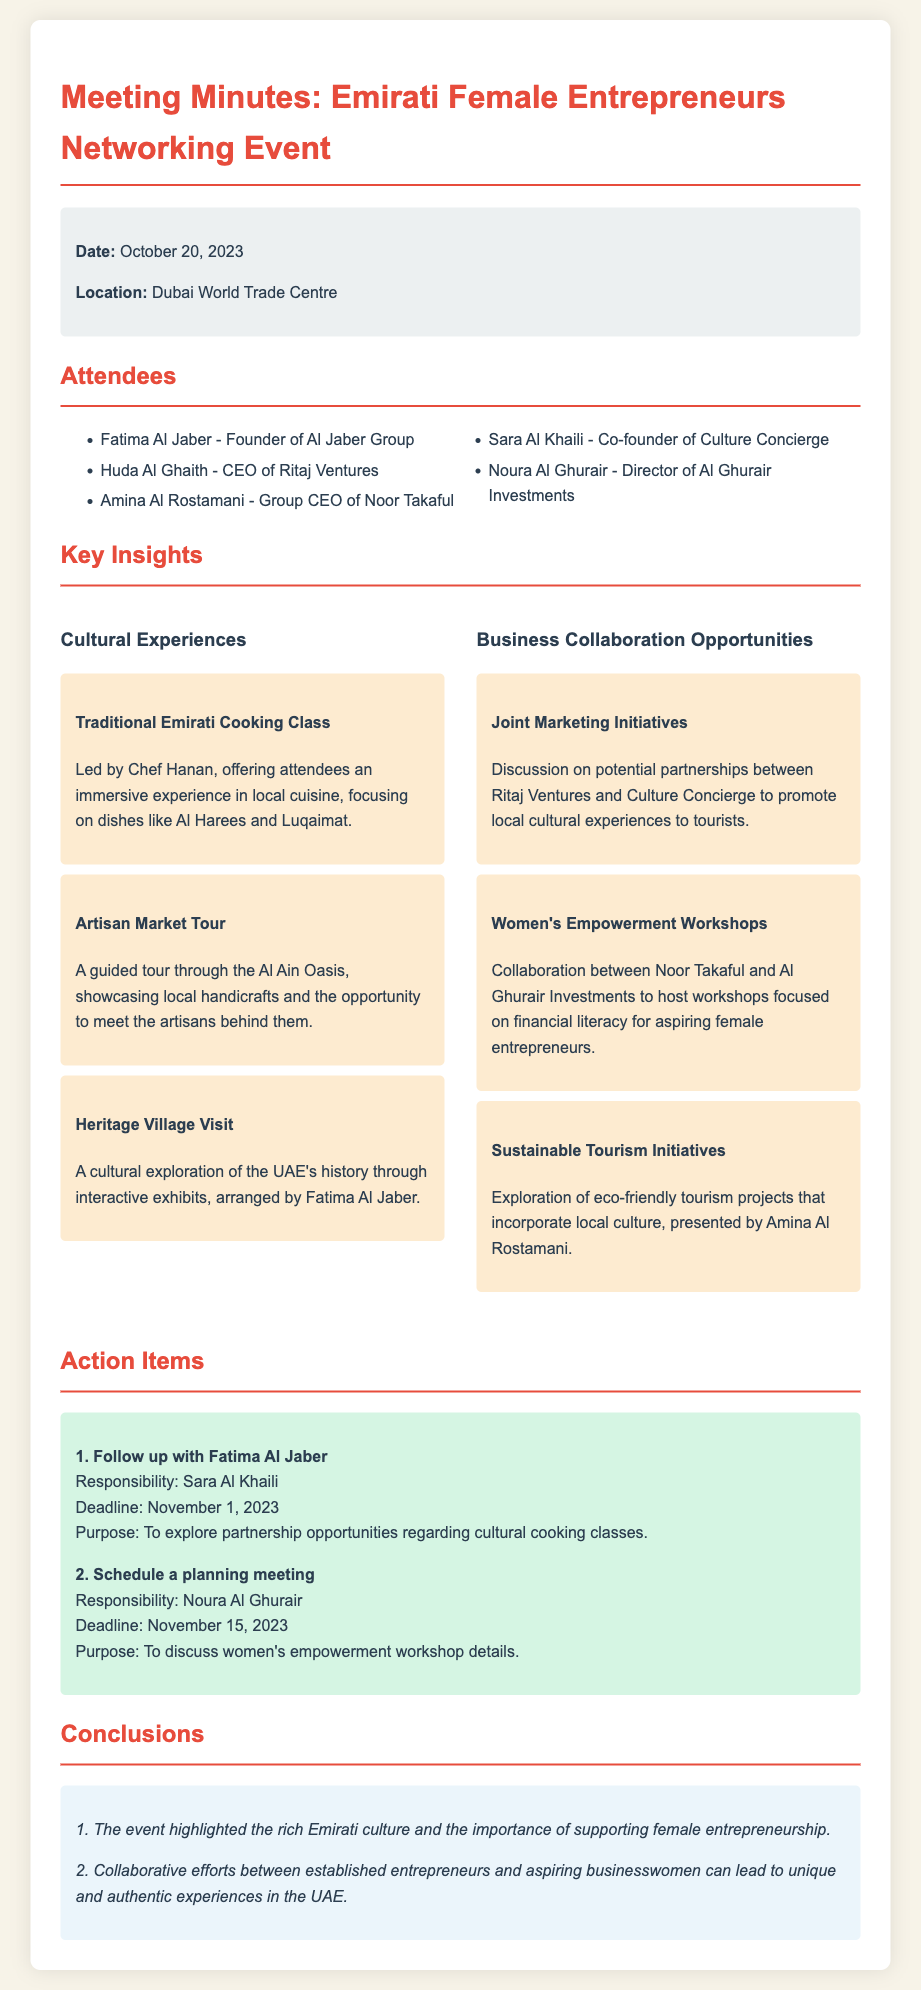What is the date of the networking event? The date of the networking event is mentioned in the document under event details.
Answer: October 20, 2023 Where was the event held? The location of the event is provided in the event details section of the document.
Answer: Dubai World Trade Centre Who is the founder of Al Jaber Group? The document lists attendees and their titles, including the founder of Al Jaber Group.
Answer: Fatima Al Jaber What is one of the cultural experiences mentioned? The insights section details different cultural experiences offered during the event.
Answer: Traditional Emirati Cooking Class What type of collaboration is discussed between Ritaj Ventures and Culture Concierge? The business collaboration opportunities section outlines discussions on initiatives between different parties.
Answer: Joint Marketing Initiatives Which organization is hosting workshops for aspiring female entrepreneurs? The document lists organizations collaborating on women's empowerment workshops.
Answer: Noor Takaful What is the deadline for following up with Fatima Al Jaber? The action items section specifies deadlines for follow-ups related to actions discussed.
Answer: November 1, 2023 What is a key conclusion from the event? The conclusions section summarizes important takeaways from the event.
Answer: Supporting female entrepreneurship Who is responsible for scheduling a planning meeting? The action items list assigns responsibilities for follow-up actions to specific individuals.
Answer: Noura Al Ghurair 